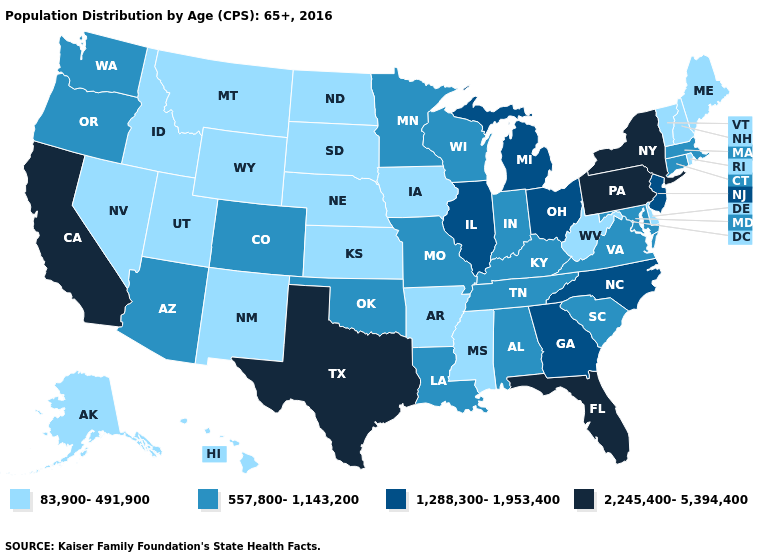Is the legend a continuous bar?
Give a very brief answer. No. Name the states that have a value in the range 1,288,300-1,953,400?
Concise answer only. Georgia, Illinois, Michigan, New Jersey, North Carolina, Ohio. What is the value of Minnesota?
Short answer required. 557,800-1,143,200. Which states have the highest value in the USA?
Concise answer only. California, Florida, New York, Pennsylvania, Texas. Name the states that have a value in the range 2,245,400-5,394,400?
Be succinct. California, Florida, New York, Pennsylvania, Texas. What is the value of New Jersey?
Write a very short answer. 1,288,300-1,953,400. What is the lowest value in the USA?
Short answer required. 83,900-491,900. What is the value of Colorado?
Quick response, please. 557,800-1,143,200. What is the value of Vermont?
Keep it brief. 83,900-491,900. Which states have the highest value in the USA?
Be succinct. California, Florida, New York, Pennsylvania, Texas. How many symbols are there in the legend?
Quick response, please. 4. Name the states that have a value in the range 2,245,400-5,394,400?
Answer briefly. California, Florida, New York, Pennsylvania, Texas. Which states hav the highest value in the MidWest?
Short answer required. Illinois, Michigan, Ohio. What is the highest value in the USA?
Be succinct. 2,245,400-5,394,400. What is the highest value in the USA?
Concise answer only. 2,245,400-5,394,400. 